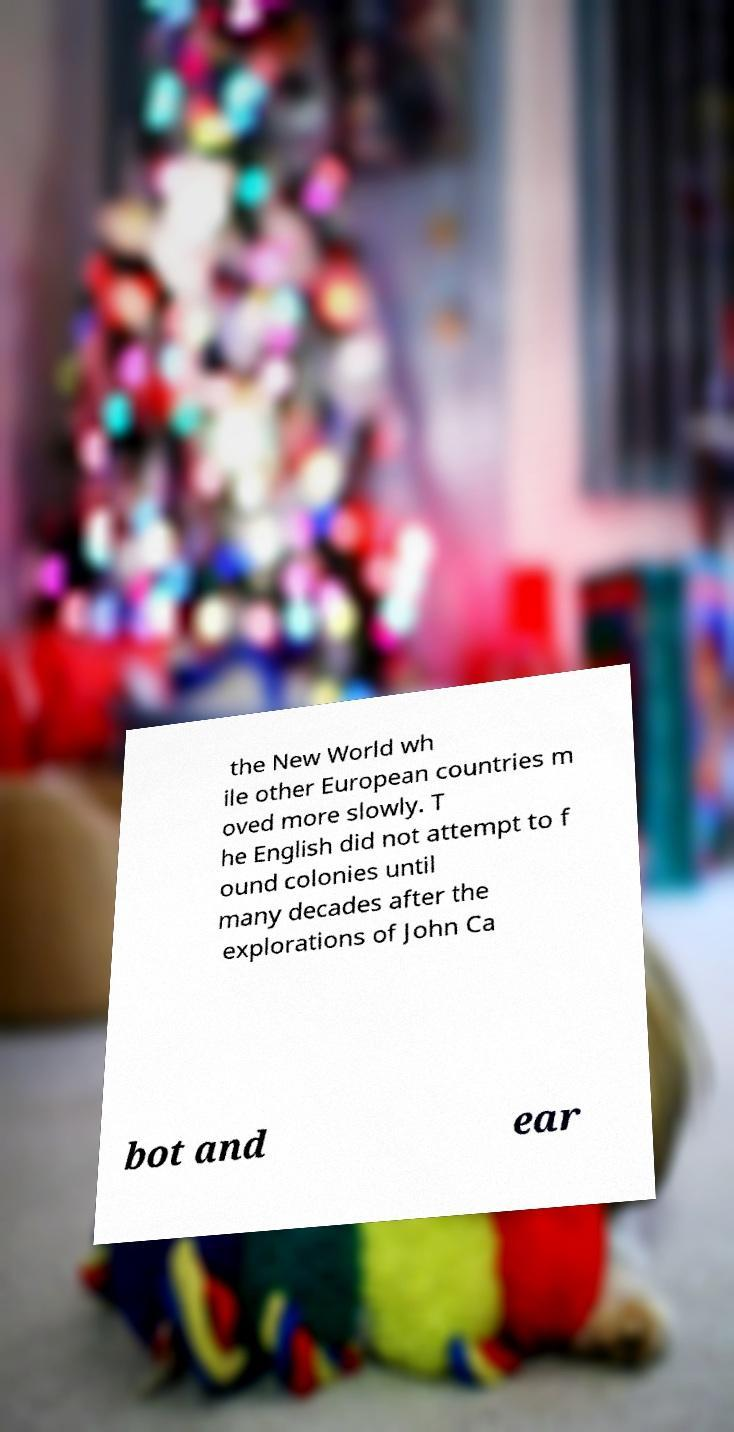Could you extract and type out the text from this image? the New World wh ile other European countries m oved more slowly. T he English did not attempt to f ound colonies until many decades after the explorations of John Ca bot and ear 